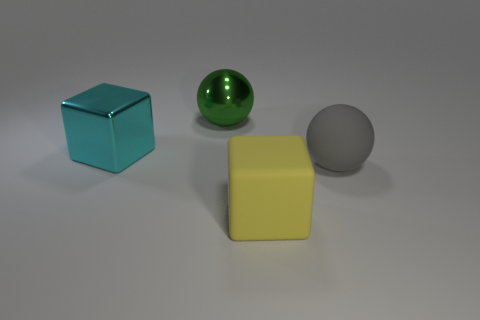There is a big rubber object that is in front of the large matte sphere; is its shape the same as the big gray object?
Give a very brief answer. No. There is a object that is both in front of the green object and on the left side of the big yellow block; what is its shape?
Offer a very short reply. Cube. The green thing that is the same shape as the gray object is what size?
Ensure brevity in your answer.  Large. Is the shape of the yellow rubber thing the same as the big cyan object?
Keep it short and to the point. Yes. The other large metal thing that is the same shape as the large yellow thing is what color?
Offer a very short reply. Cyan. There is a object that is both to the left of the large rubber sphere and on the right side of the green ball; what is its color?
Offer a very short reply. Yellow. How many large cubes have the same material as the big gray ball?
Ensure brevity in your answer.  1. What number of large cyan metal cubes are there?
Offer a very short reply. 1. What is the big ball right of the sphere that is to the left of the gray matte thing made of?
Keep it short and to the point. Rubber. What is the size of the block that is to the right of the shiny cube in front of the big thing behind the large metallic cube?
Provide a succinct answer. Large. 